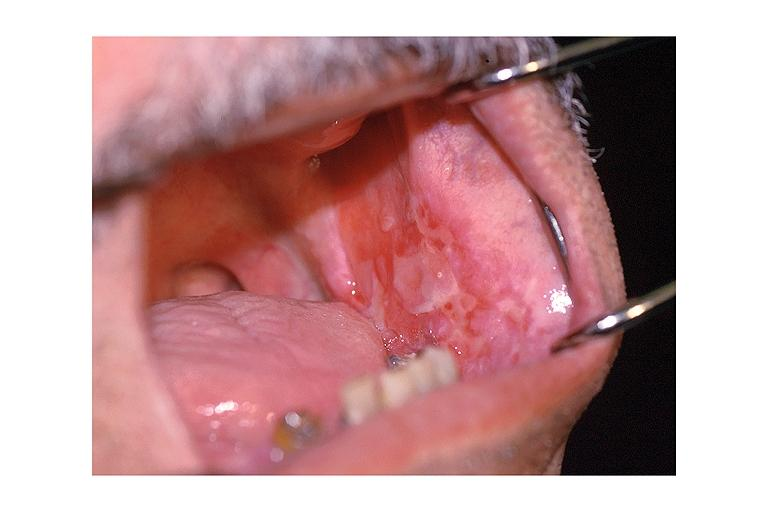does this image show cicatricial pemphigoid?
Answer the question using a single word or phrase. Yes 